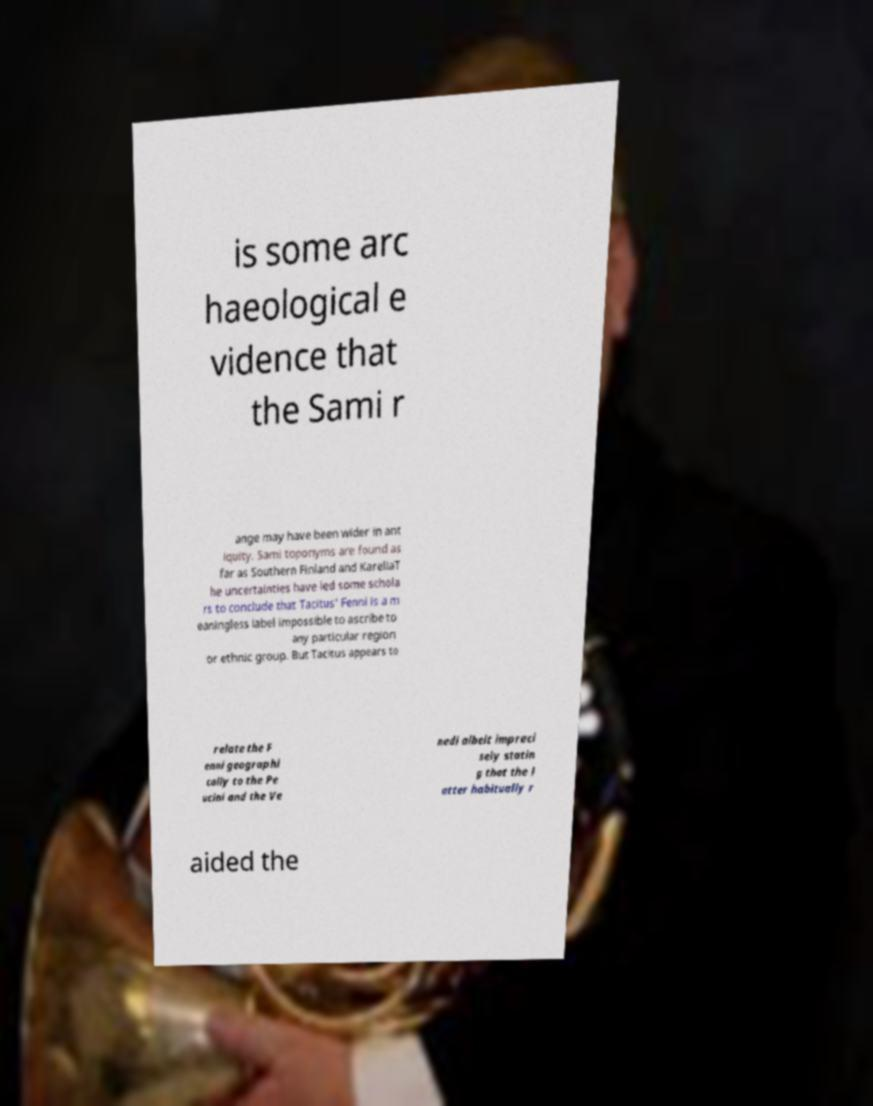Can you accurately transcribe the text from the provided image for me? is some arc haeological e vidence that the Sami r ange may have been wider in ant iquity. Sami toponyms are found as far as Southern Finland and KareliaT he uncertainties have led some schola rs to conclude that Tacitus' Fenni is a m eaningless label impossible to ascribe to any particular region or ethnic group. But Tacitus appears to relate the F enni geographi cally to the Pe ucini and the Ve nedi albeit impreci sely statin g that the l atter habitually r aided the 